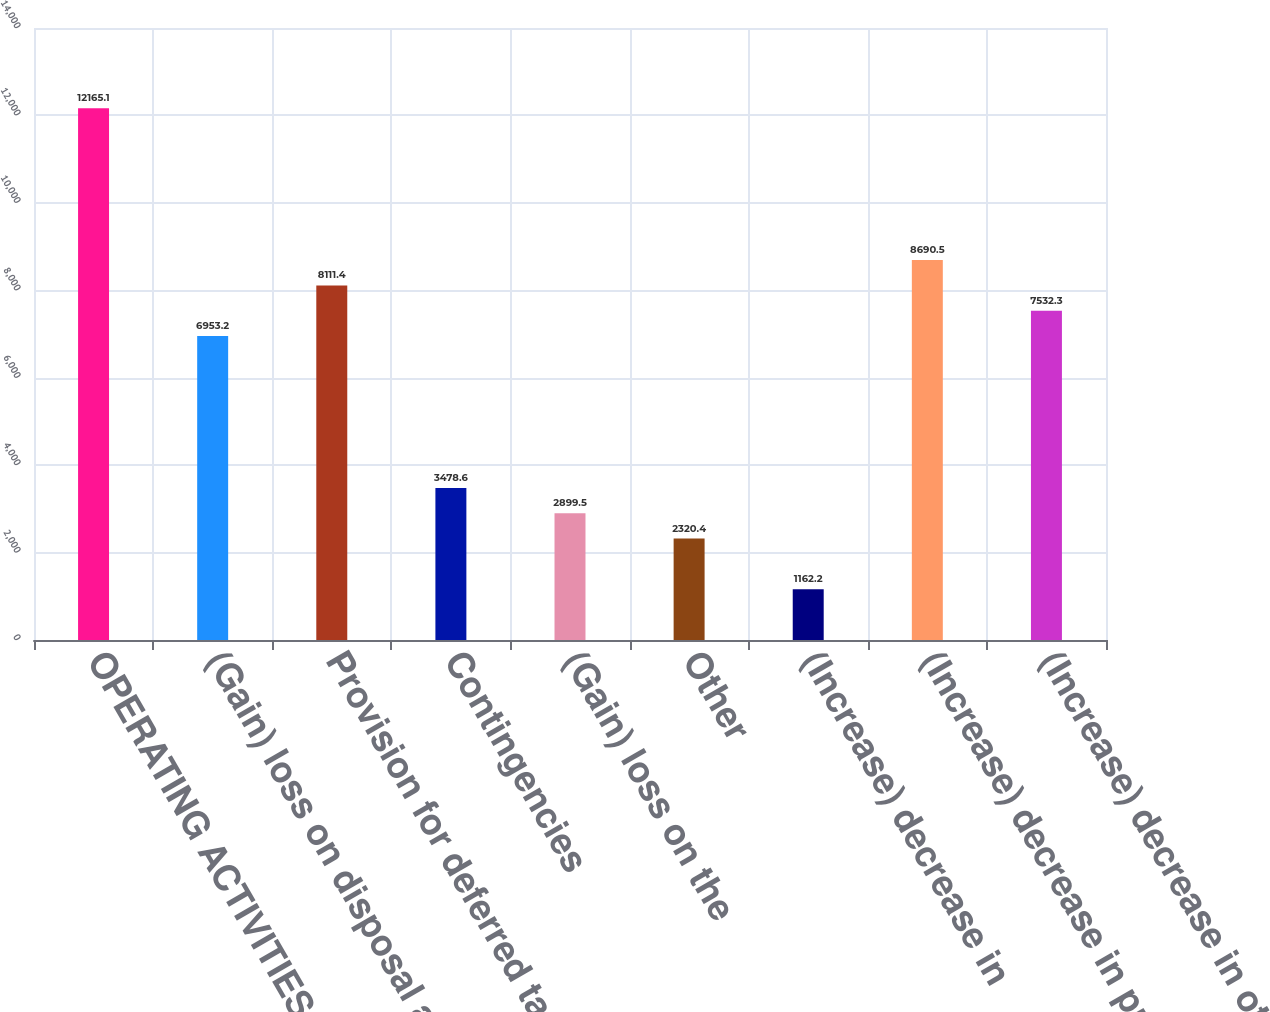Convert chart to OTSL. <chart><loc_0><loc_0><loc_500><loc_500><bar_chart><fcel>OPERATING ACTIVITIES Net<fcel>(Gain) loss on disposal and<fcel>Provision for deferred taxes<fcel>Contingencies<fcel>(Gain) loss on the<fcel>Other<fcel>(Increase) decrease in<fcel>(Increase) decrease in prepaid<fcel>(Increase) decrease in other<nl><fcel>12165.1<fcel>6953.2<fcel>8111.4<fcel>3478.6<fcel>2899.5<fcel>2320.4<fcel>1162.2<fcel>8690.5<fcel>7532.3<nl></chart> 